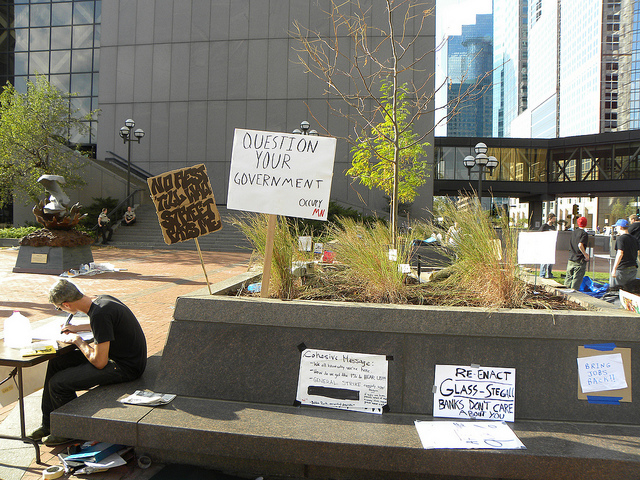What is the man participating in?
A. protest
B. play
C. concert
D. sale The man is participating in a protest, as evidenced by the signs around him which display messages typically associated with political or social activism, such as 'QUESTION YOUR GOVERNMENT' and calls to 'Re-enact Glass-Steagall', referring to a piece of financial legislation. Protests are public demonstrations expressing opposition to particular policies or social issues, and the materials present here are strongly indicative of such an event. 